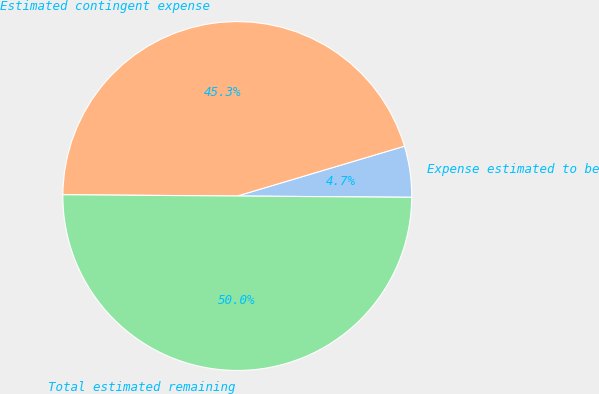<chart> <loc_0><loc_0><loc_500><loc_500><pie_chart><fcel>Expense estimated to be<fcel>Estimated contingent expense<fcel>Total estimated remaining<nl><fcel>4.73%<fcel>45.27%<fcel>50.0%<nl></chart> 